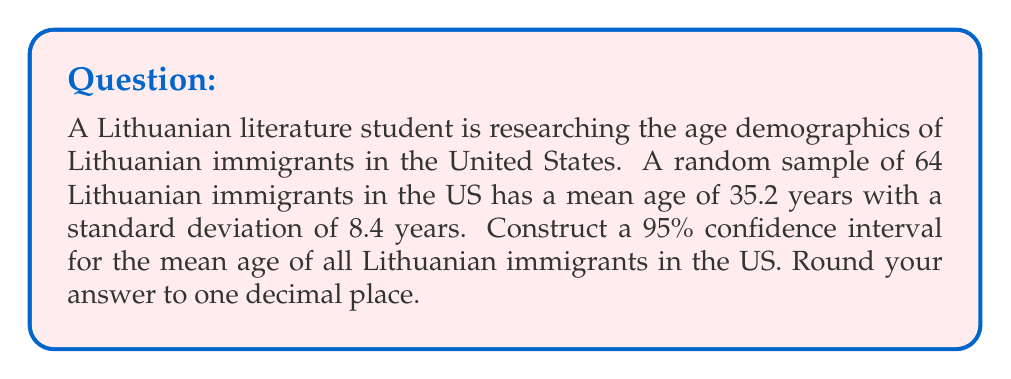Solve this math problem. Let's approach this step-by-step:

1) We are given:
   - Sample size: $n = 64$
   - Sample mean: $\bar{x} = 35.2$ years
   - Sample standard deviation: $s = 8.4$ years
   - Confidence level: 95%

2) For a 95% confidence interval, we use a z-score of 1.96.

3) The formula for the confidence interval is:

   $$\bar{x} \pm z\frac{s}{\sqrt{n}}$$

4) Let's calculate the margin of error:

   $$\text{Margin of Error} = z\frac{s}{\sqrt{n}} = 1.96 \cdot \frac{8.4}{\sqrt{64}} = 1.96 \cdot \frac{8.4}{8} = 2.058$$

5) Now, we can calculate the lower and upper bounds of the confidence interval:

   Lower bound: $35.2 - 2.058 = 33.142$
   Upper bound: $35.2 + 2.058 = 37.258$

6) Rounding to one decimal place:

   Lower bound: 33.1
   Upper bound: 37.3

Therefore, we can be 95% confident that the true mean age of all Lithuanian immigrants in the US is between 33.1 and 37.3 years.
Answer: (33.1, 37.3) years 